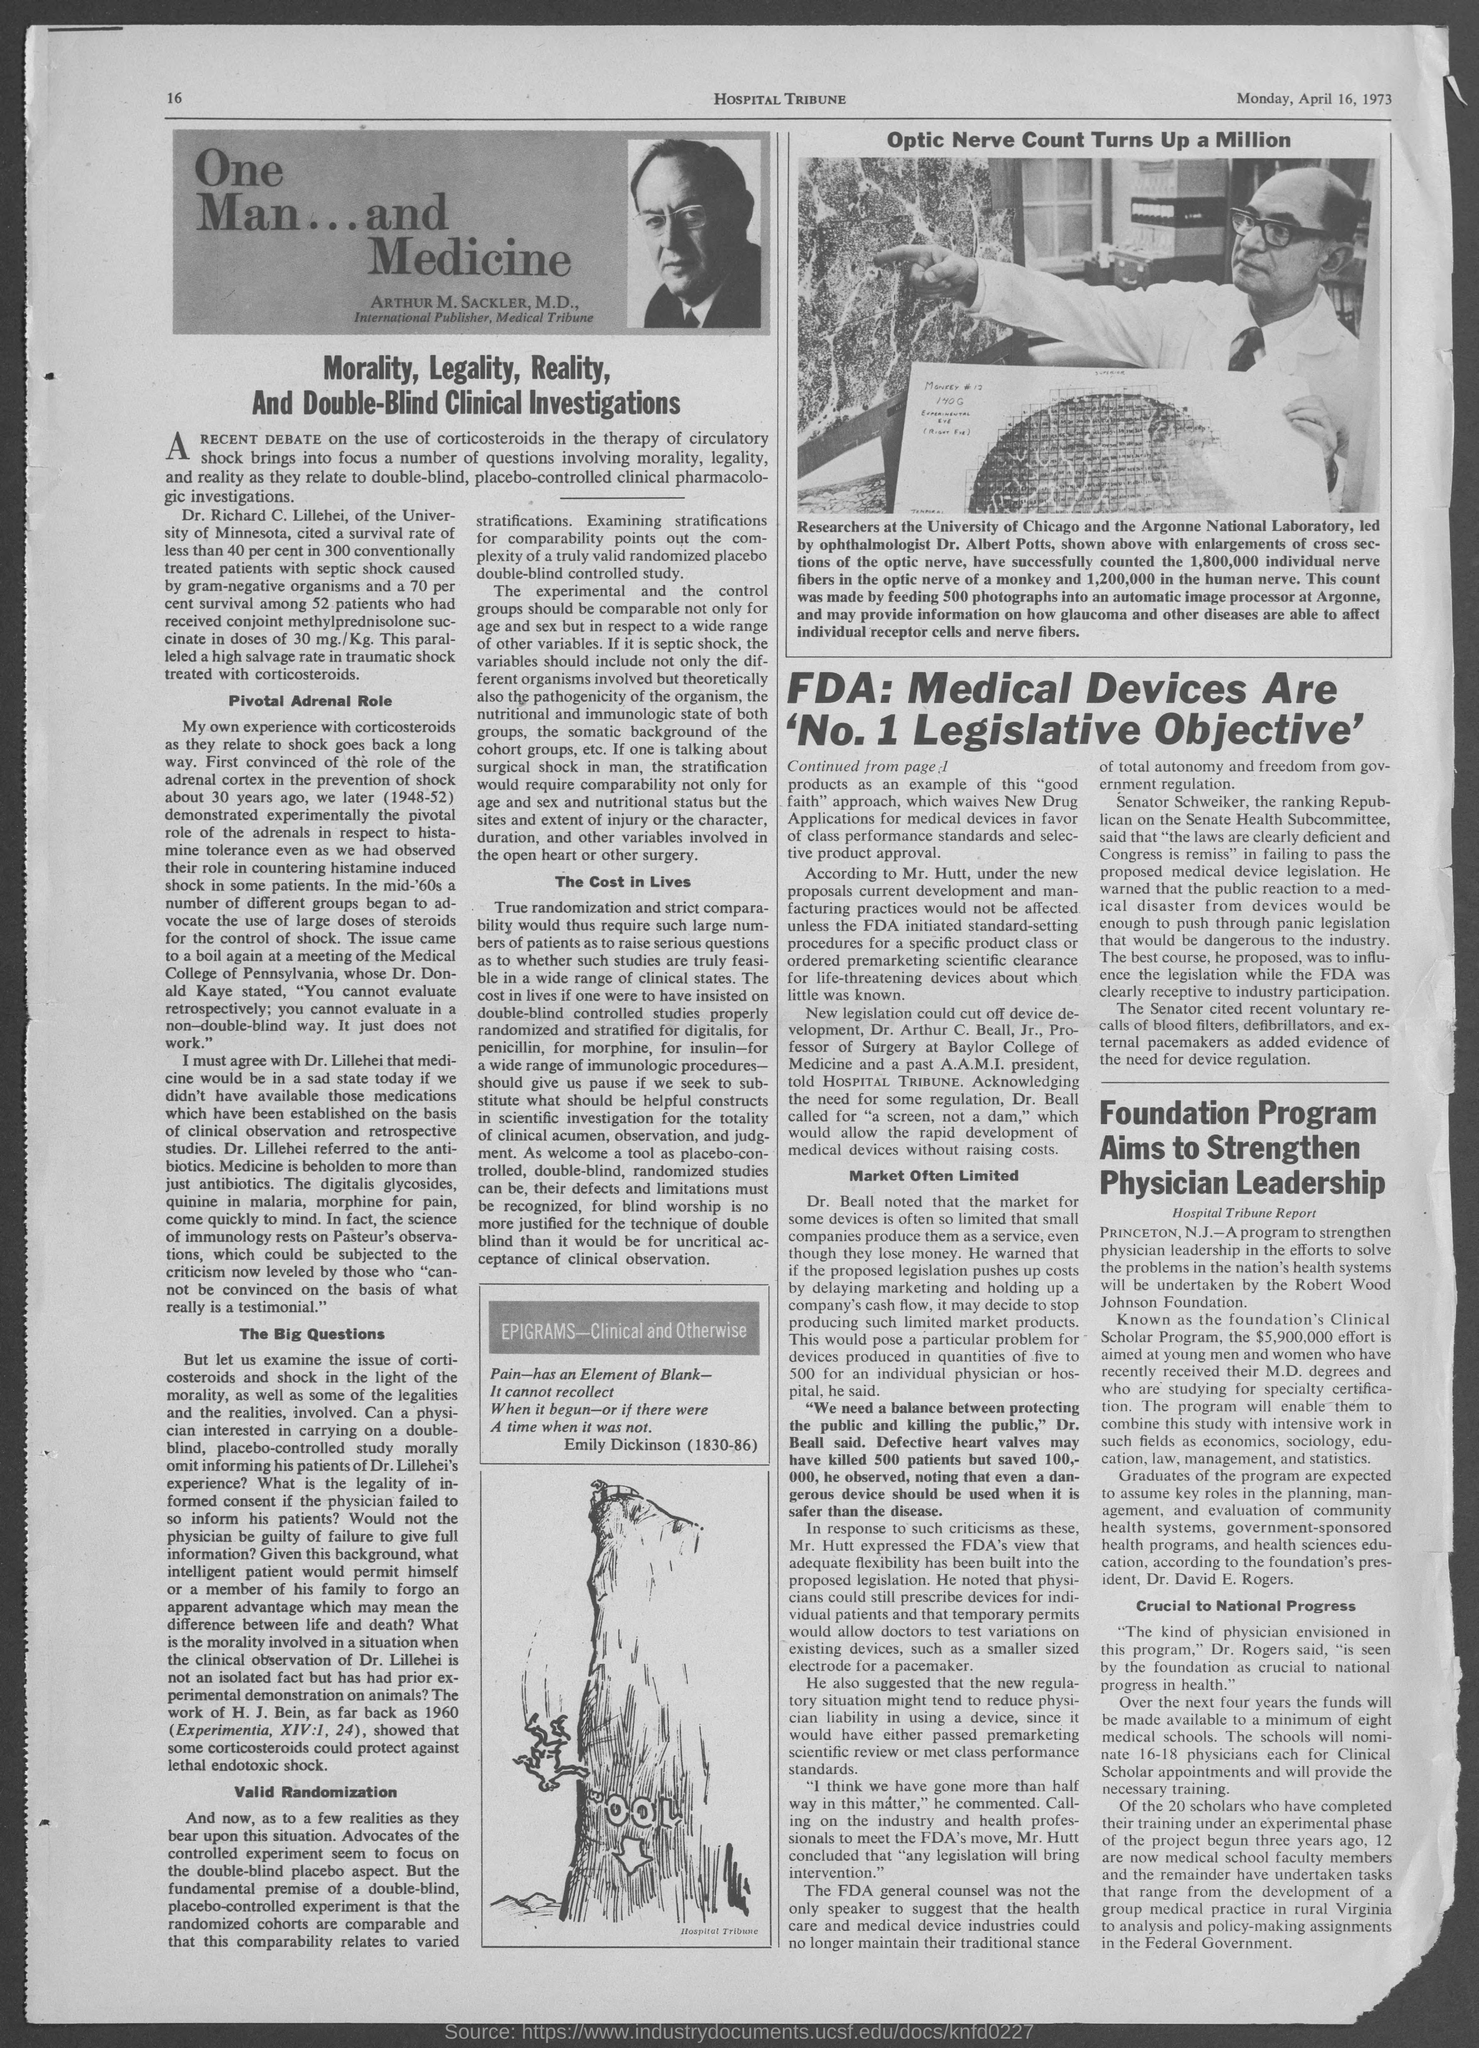Outline some significant characteristics in this image. The paper is the Hospital Tribune. 